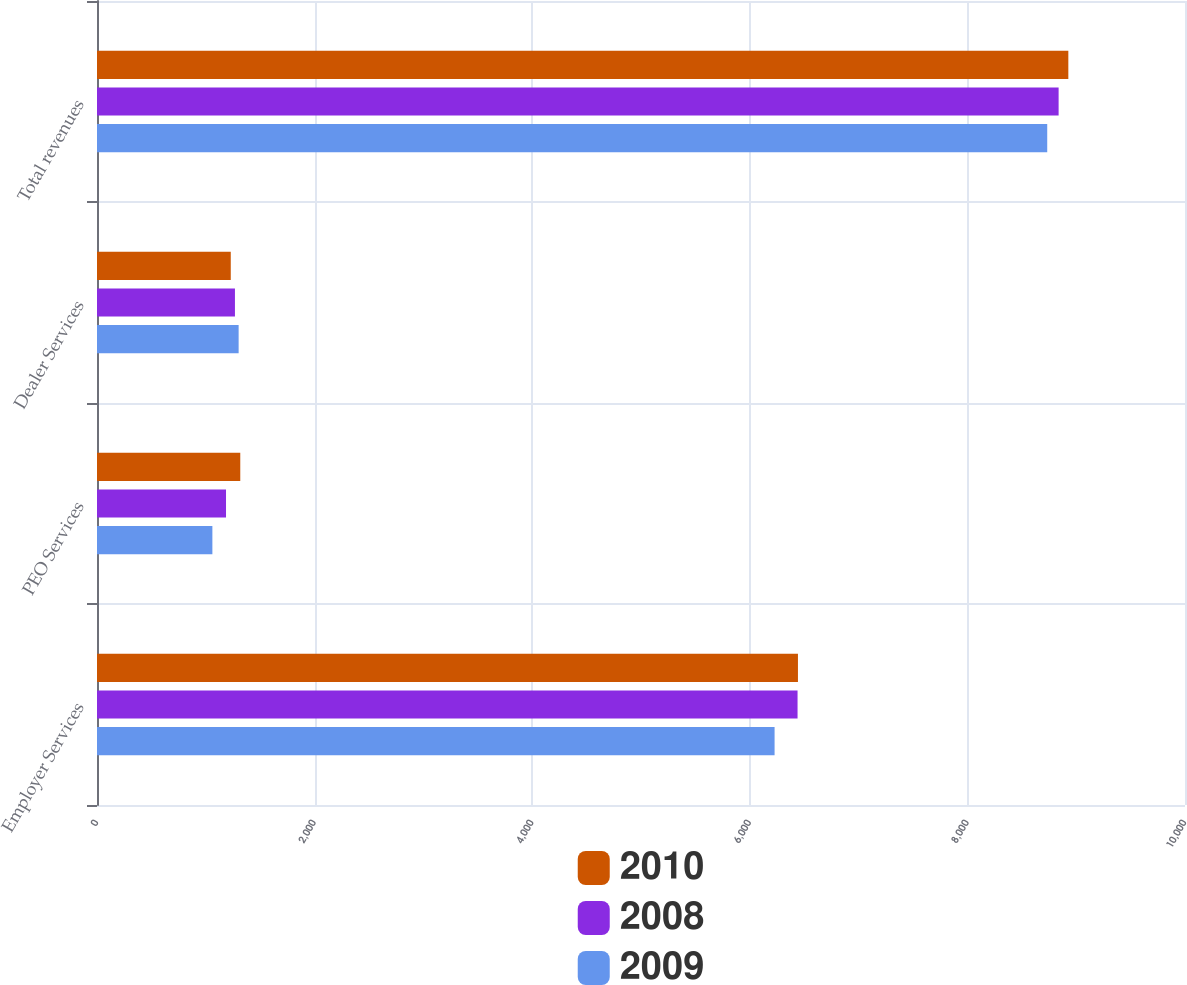<chart> <loc_0><loc_0><loc_500><loc_500><stacked_bar_chart><ecel><fcel>Employer Services<fcel>PEO Services<fcel>Dealer Services<fcel>Total revenues<nl><fcel>2010<fcel>6442.6<fcel>1316.8<fcel>1229.4<fcel>8927.7<nl><fcel>2008<fcel>6438.9<fcel>1185.8<fcel>1267.9<fcel>8838.4<nl><fcel>2009<fcel>6227.8<fcel>1060.5<fcel>1301.8<fcel>8733.7<nl></chart> 